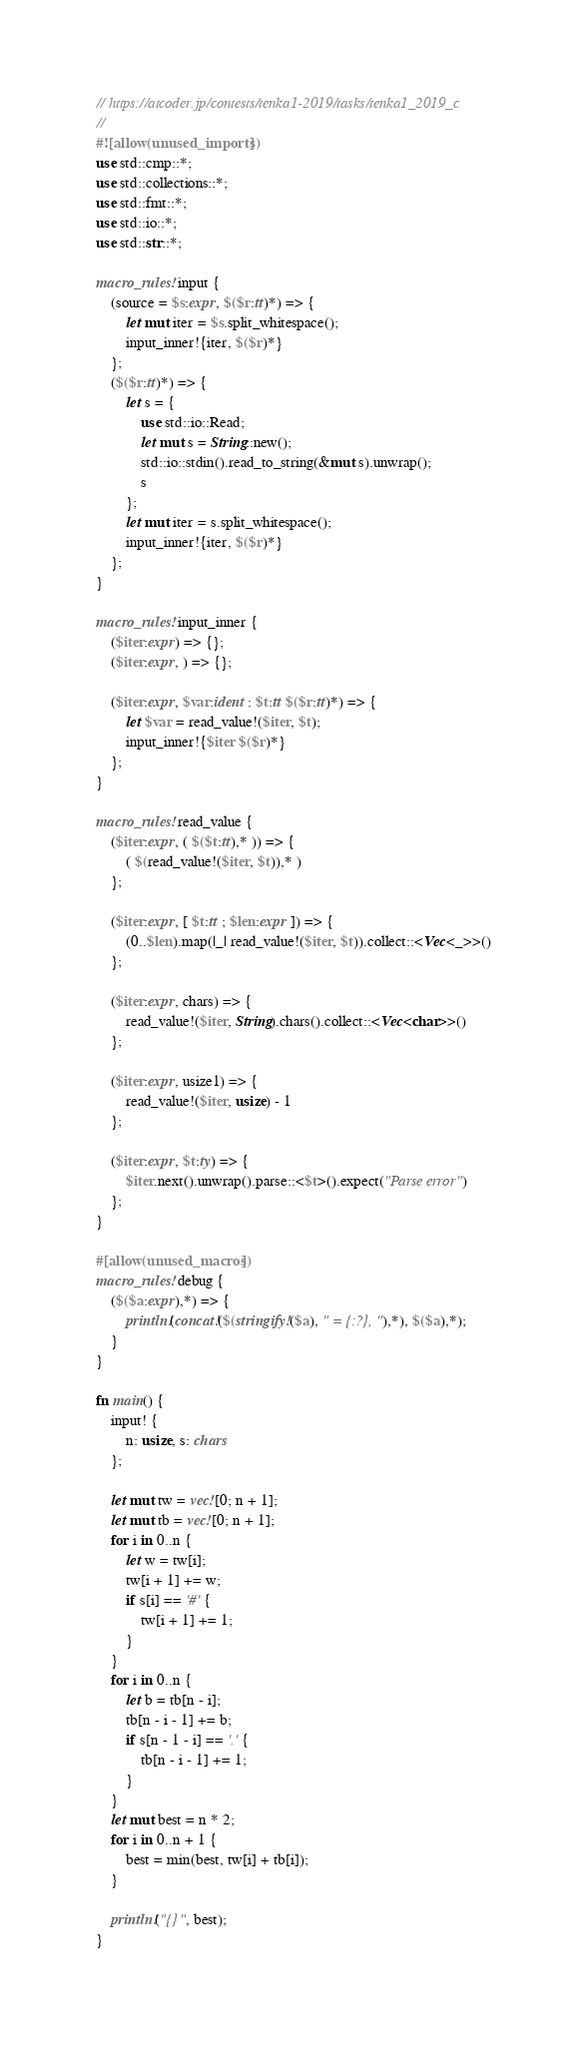Convert code to text. <code><loc_0><loc_0><loc_500><loc_500><_Rust_>// https://atcoder.jp/contests/tenka1-2019/tasks/tenka1_2019_c
//
#![allow(unused_imports)]
use std::cmp::*;
use std::collections::*;
use std::fmt::*;
use std::io::*;
use std::str::*;

macro_rules! input {
    (source = $s:expr, $($r:tt)*) => {
        let mut iter = $s.split_whitespace();
        input_inner!{iter, $($r)*}
    };
    ($($r:tt)*) => {
        let s = {
            use std::io::Read;
            let mut s = String::new();
            std::io::stdin().read_to_string(&mut s).unwrap();
            s
        };
        let mut iter = s.split_whitespace();
        input_inner!{iter, $($r)*}
    };
}

macro_rules! input_inner {
    ($iter:expr) => {};
    ($iter:expr, ) => {};

    ($iter:expr, $var:ident : $t:tt $($r:tt)*) => {
        let $var = read_value!($iter, $t);
        input_inner!{$iter $($r)*}
    };
}

macro_rules! read_value {
    ($iter:expr, ( $($t:tt),* )) => {
        ( $(read_value!($iter, $t)),* )
    };

    ($iter:expr, [ $t:tt ; $len:expr ]) => {
        (0..$len).map(|_| read_value!($iter, $t)).collect::<Vec<_>>()
    };

    ($iter:expr, chars) => {
        read_value!($iter, String).chars().collect::<Vec<char>>()
    };

    ($iter:expr, usize1) => {
        read_value!($iter, usize) - 1
    };

    ($iter:expr, $t:ty) => {
        $iter.next().unwrap().parse::<$t>().expect("Parse error")
    };
}

#[allow(unused_macros)]
macro_rules! debug {
    ($($a:expr),*) => {
        println!(concat!($(stringify!($a), " = {:?}, "),*), $($a),*);
    }
}

fn main() {
    input! {
        n: usize, s: chars
    };

    let mut tw = vec![0; n + 1];
    let mut tb = vec![0; n + 1];
    for i in 0..n {
        let w = tw[i];
        tw[i + 1] += w;
        if s[i] == '#' {
            tw[i + 1] += 1;
        }
    }
    for i in 0..n {
        let b = tb[n - i];
        tb[n - i - 1] += b;
        if s[n - 1 - i] == '.' {
            tb[n - i - 1] += 1;
        }
    }
    let mut best = n * 2;
    for i in 0..n + 1 {
        best = min(best, tw[i] + tb[i]);
    }

    println!("{}", best);
}
</code> 